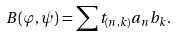Convert formula to latex. <formula><loc_0><loc_0><loc_500><loc_500>B ( \varphi , \psi ) = \sum t _ { ( n , k ) } a _ { n } b _ { k } .</formula> 